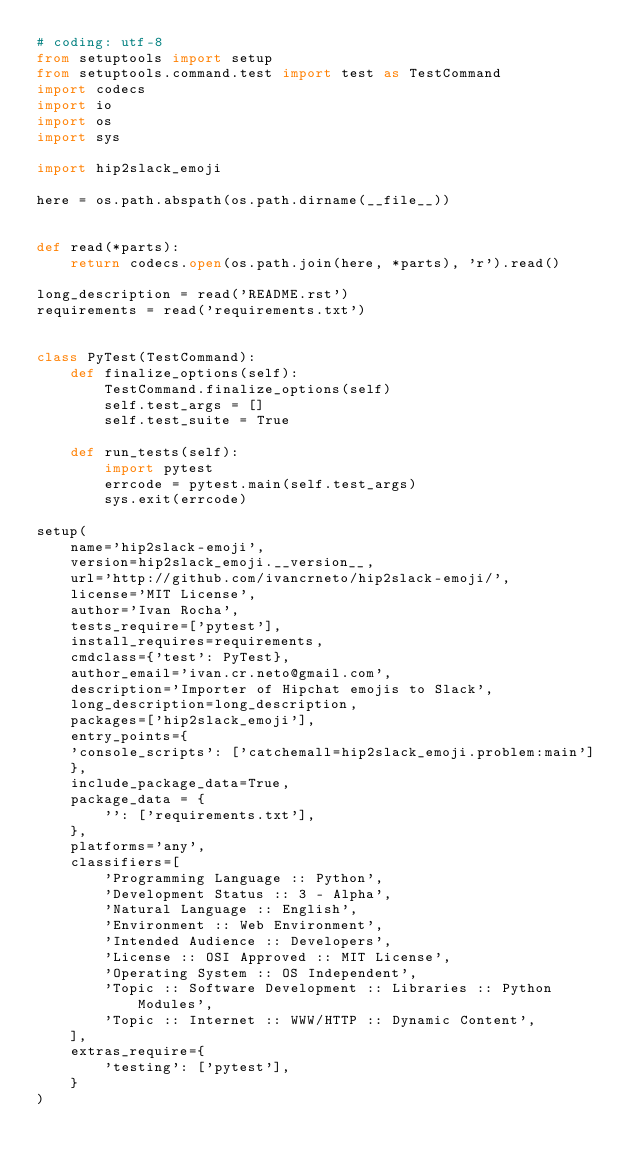<code> <loc_0><loc_0><loc_500><loc_500><_Python_># coding: utf-8
from setuptools import setup
from setuptools.command.test import test as TestCommand
import codecs
import io
import os
import sys

import hip2slack_emoji

here = os.path.abspath(os.path.dirname(__file__))


def read(*parts):
    return codecs.open(os.path.join(here, *parts), 'r').read()

long_description = read('README.rst')
requirements = read('requirements.txt')


class PyTest(TestCommand):
    def finalize_options(self):
        TestCommand.finalize_options(self)
        self.test_args = []
        self.test_suite = True

    def run_tests(self):
        import pytest
        errcode = pytest.main(self.test_args)
        sys.exit(errcode)

setup(
    name='hip2slack-emoji',
    version=hip2slack_emoji.__version__,
    url='http://github.com/ivancrneto/hip2slack-emoji/',
    license='MIT License',
    author='Ivan Rocha',
    tests_require=['pytest'],
    install_requires=requirements,
    cmdclass={'test': PyTest},
    author_email='ivan.cr.neto@gmail.com',
    description='Importer of Hipchat emojis to Slack',
    long_description=long_description,
    packages=['hip2slack_emoji'],
    entry_points={
	'console_scripts': ['catchemall=hip2slack_emoji.problem:main']
    },
    include_package_data=True,
    package_data = {
        '': ['requirements.txt'],
    },
    platforms='any',
    classifiers=[
        'Programming Language :: Python',
        'Development Status :: 3 - Alpha',
        'Natural Language :: English',
        'Environment :: Web Environment',
        'Intended Audience :: Developers',
        'License :: OSI Approved :: MIT License',
        'Operating System :: OS Independent',
        'Topic :: Software Development :: Libraries :: Python Modules',
        'Topic :: Internet :: WWW/HTTP :: Dynamic Content',
    ],
    extras_require={
        'testing': ['pytest'],
    }
)
</code> 